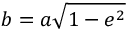<formula> <loc_0><loc_0><loc_500><loc_500>b = a { \sqrt { 1 - e ^ { 2 } } }</formula> 